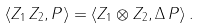<formula> <loc_0><loc_0><loc_500><loc_500>\langle Z _ { 1 } \, Z _ { 2 } , P \rangle = \langle Z _ { 1 } \otimes Z _ { 2 } , \Delta \, P \rangle \, .</formula> 